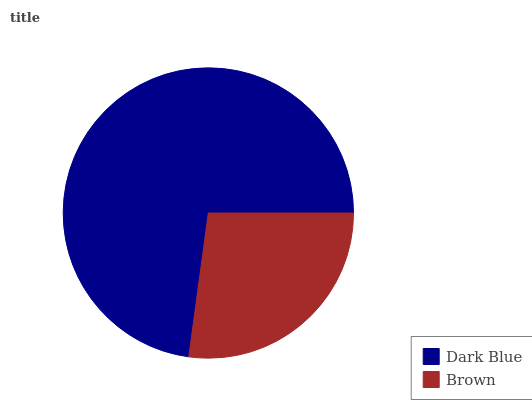Is Brown the minimum?
Answer yes or no. Yes. Is Dark Blue the maximum?
Answer yes or no. Yes. Is Brown the maximum?
Answer yes or no. No. Is Dark Blue greater than Brown?
Answer yes or no. Yes. Is Brown less than Dark Blue?
Answer yes or no. Yes. Is Brown greater than Dark Blue?
Answer yes or no. No. Is Dark Blue less than Brown?
Answer yes or no. No. Is Dark Blue the high median?
Answer yes or no. Yes. Is Brown the low median?
Answer yes or no. Yes. Is Brown the high median?
Answer yes or no. No. Is Dark Blue the low median?
Answer yes or no. No. 